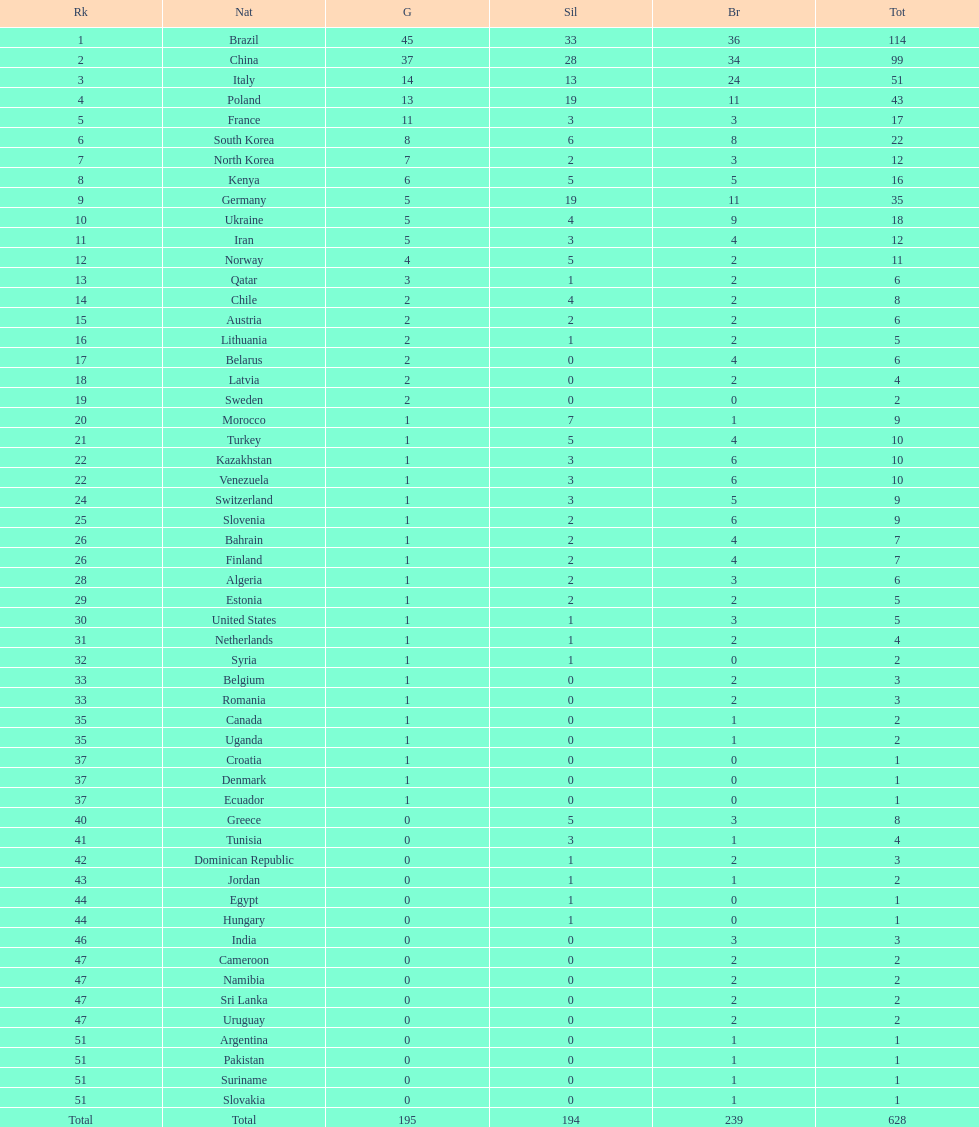Who obtained more gold medals, brazil or china? Brazil. 